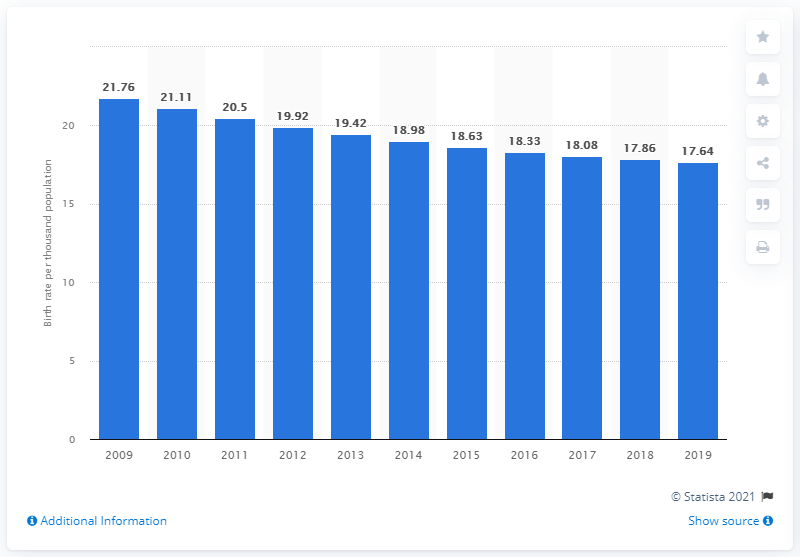Give some essential details in this illustration. According to data from 2019, the crude birth rate in India was 17.64. 